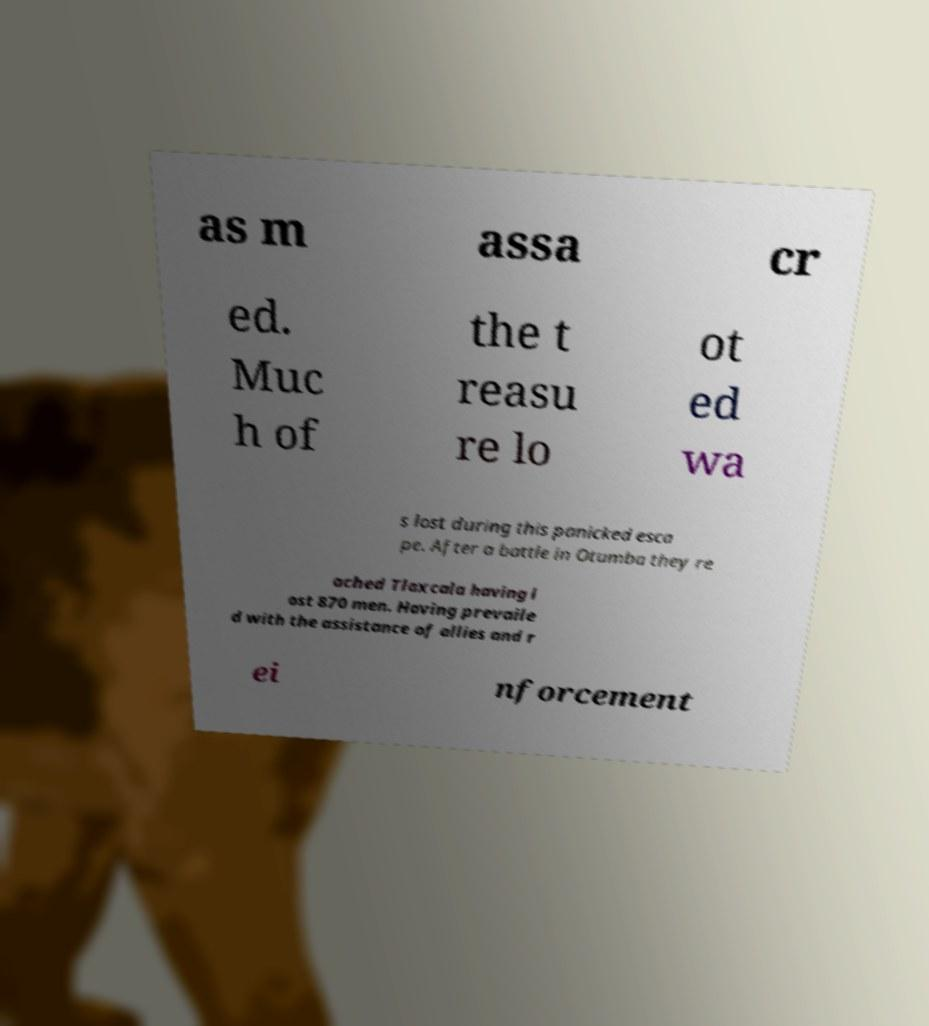Could you assist in decoding the text presented in this image and type it out clearly? as m assa cr ed. Muc h of the t reasu re lo ot ed wa s lost during this panicked esca pe. After a battle in Otumba they re ached Tlaxcala having l ost 870 men. Having prevaile d with the assistance of allies and r ei nforcement 